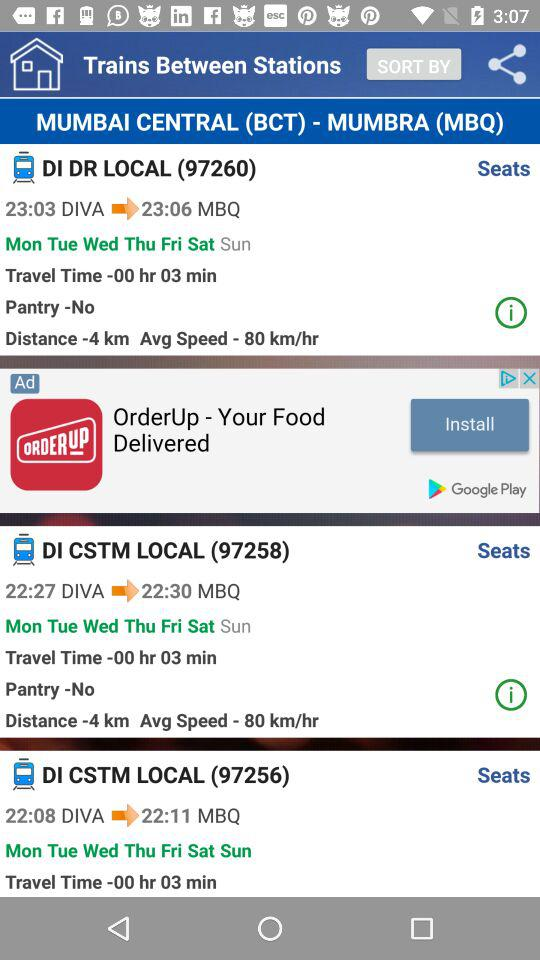Is there pantry in 97260?
Answer the question using a single word or phrase. No 